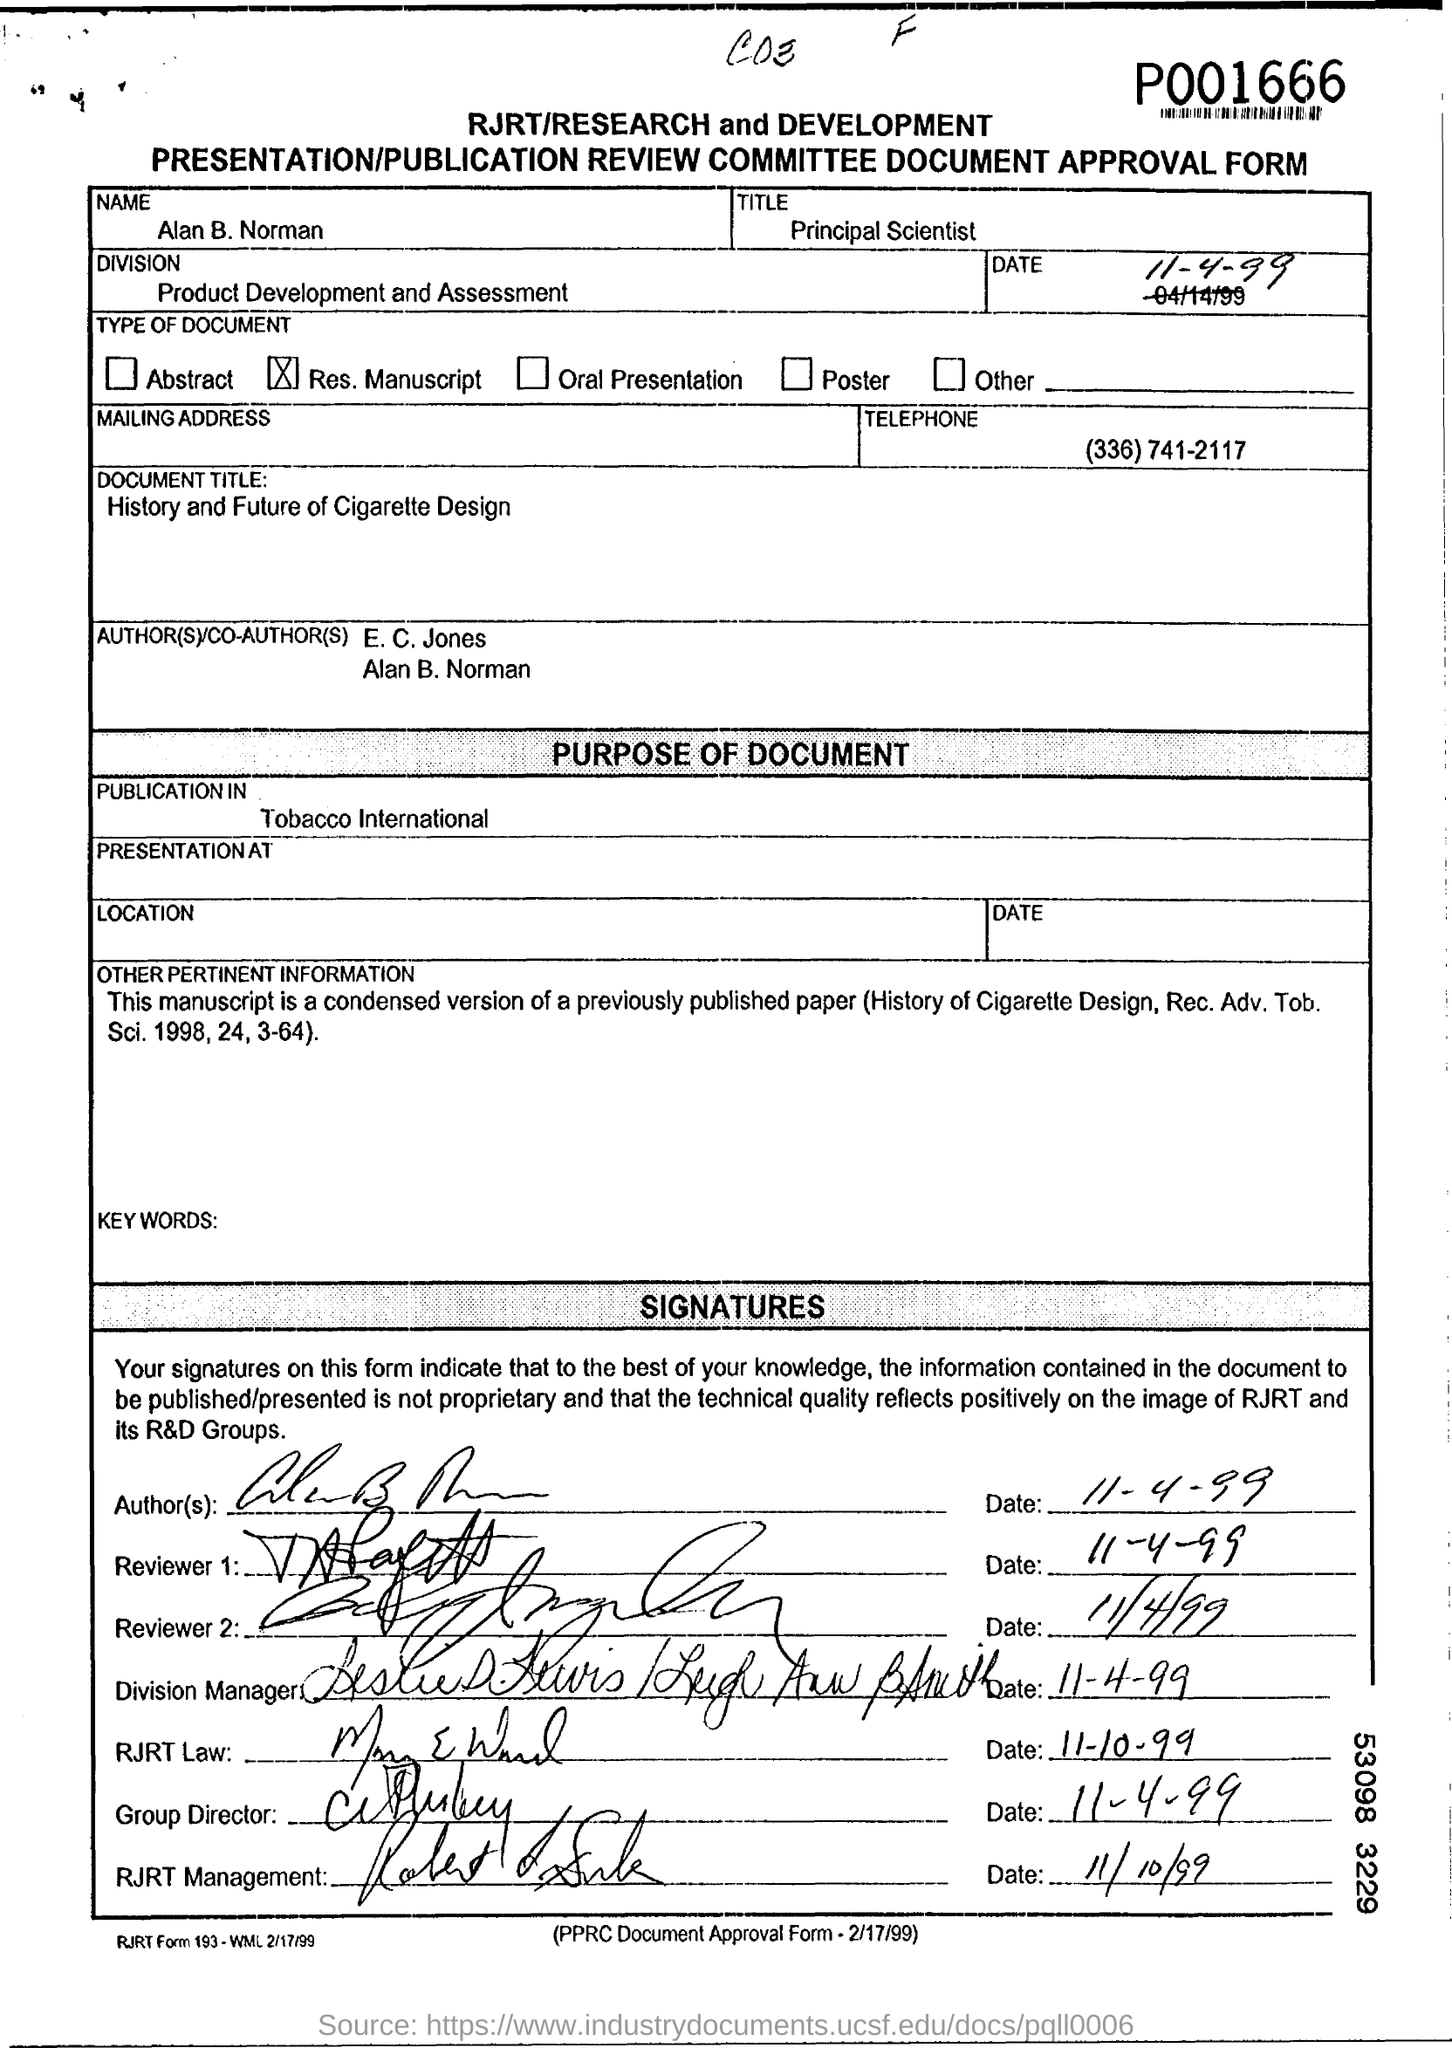Specify some key components in this picture. The document title "History and Future of Cigarette Design" is written in the Document Title Field. The name mentioned in the Approval Form is Alan B. Norman. The Division field contains the written text "Product Development and Assessment. The telephone number is (336) 741-2117. The title mentioned in the title field is "Principal Scientist". 